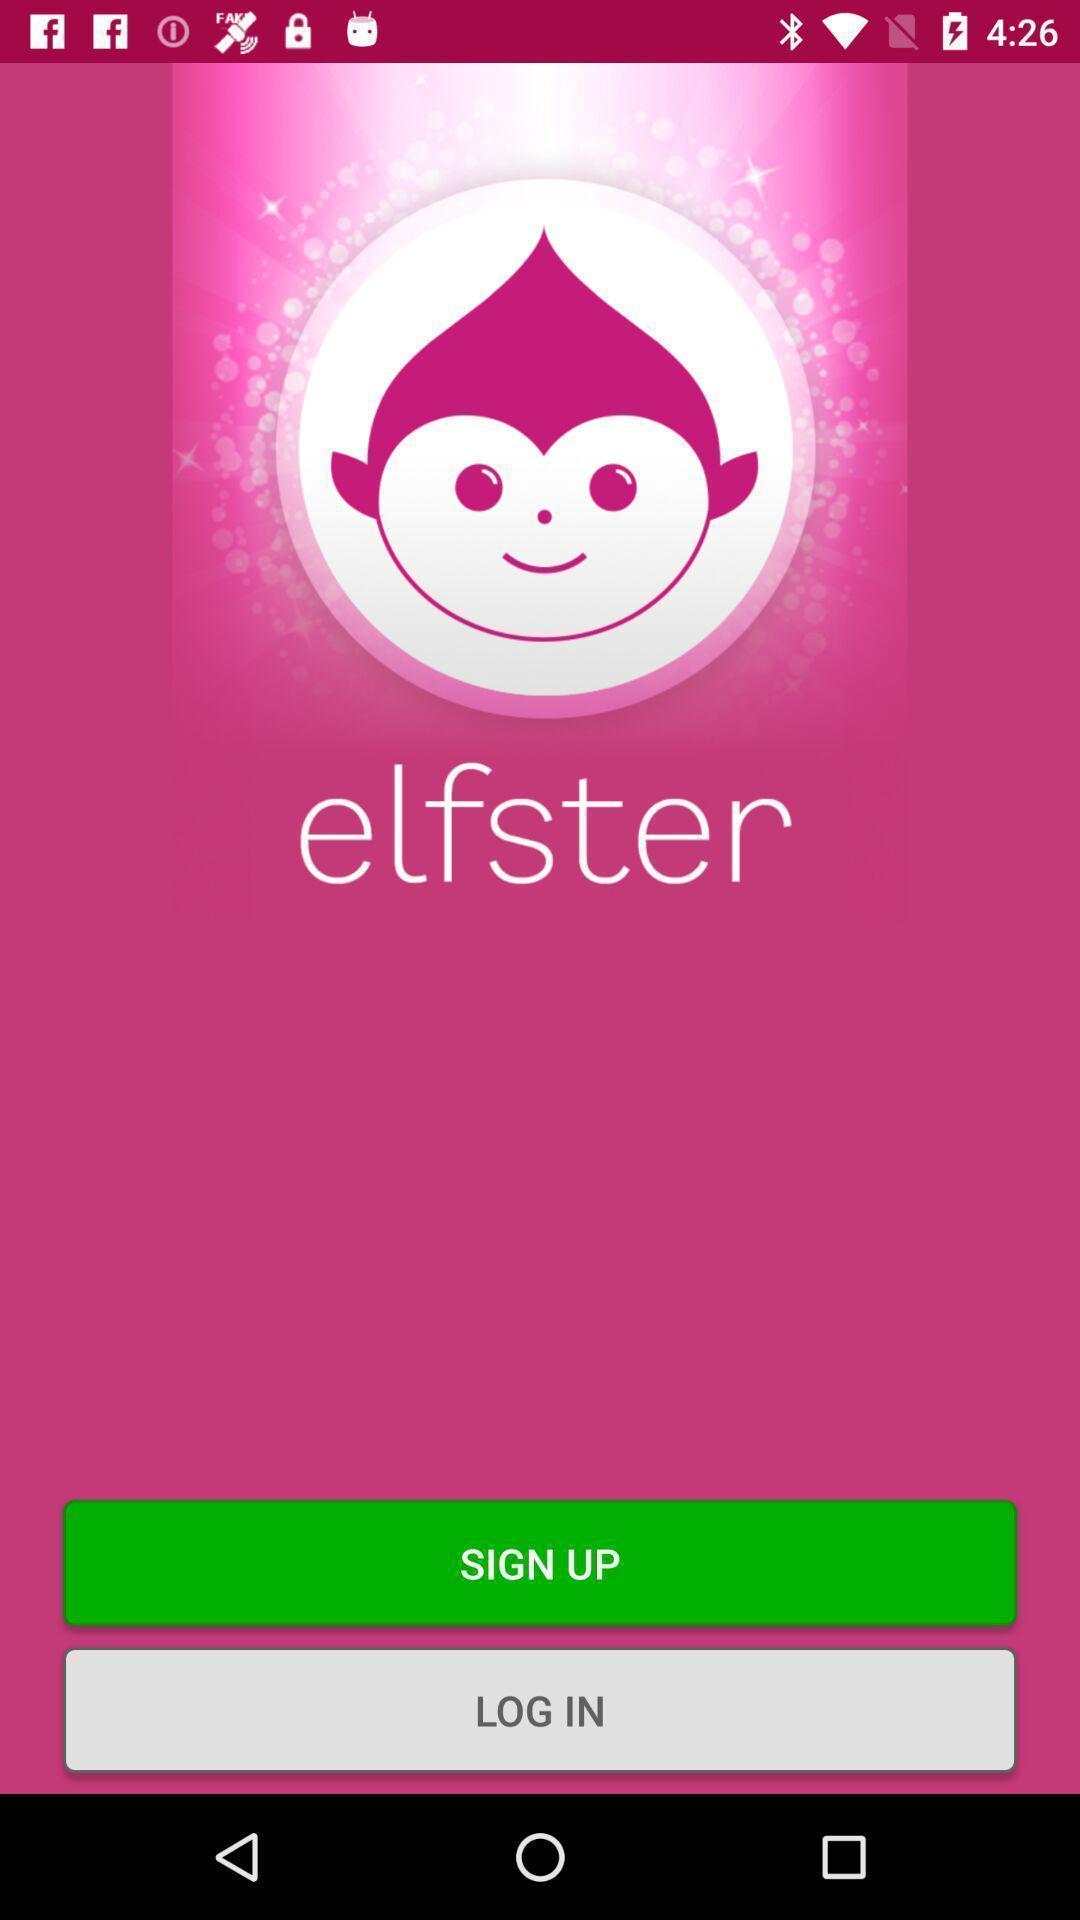Describe the visual elements of this screenshot. Welcome page. 